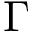Convert formula to latex. <formula><loc_0><loc_0><loc_500><loc_500>\Gamma</formula> 